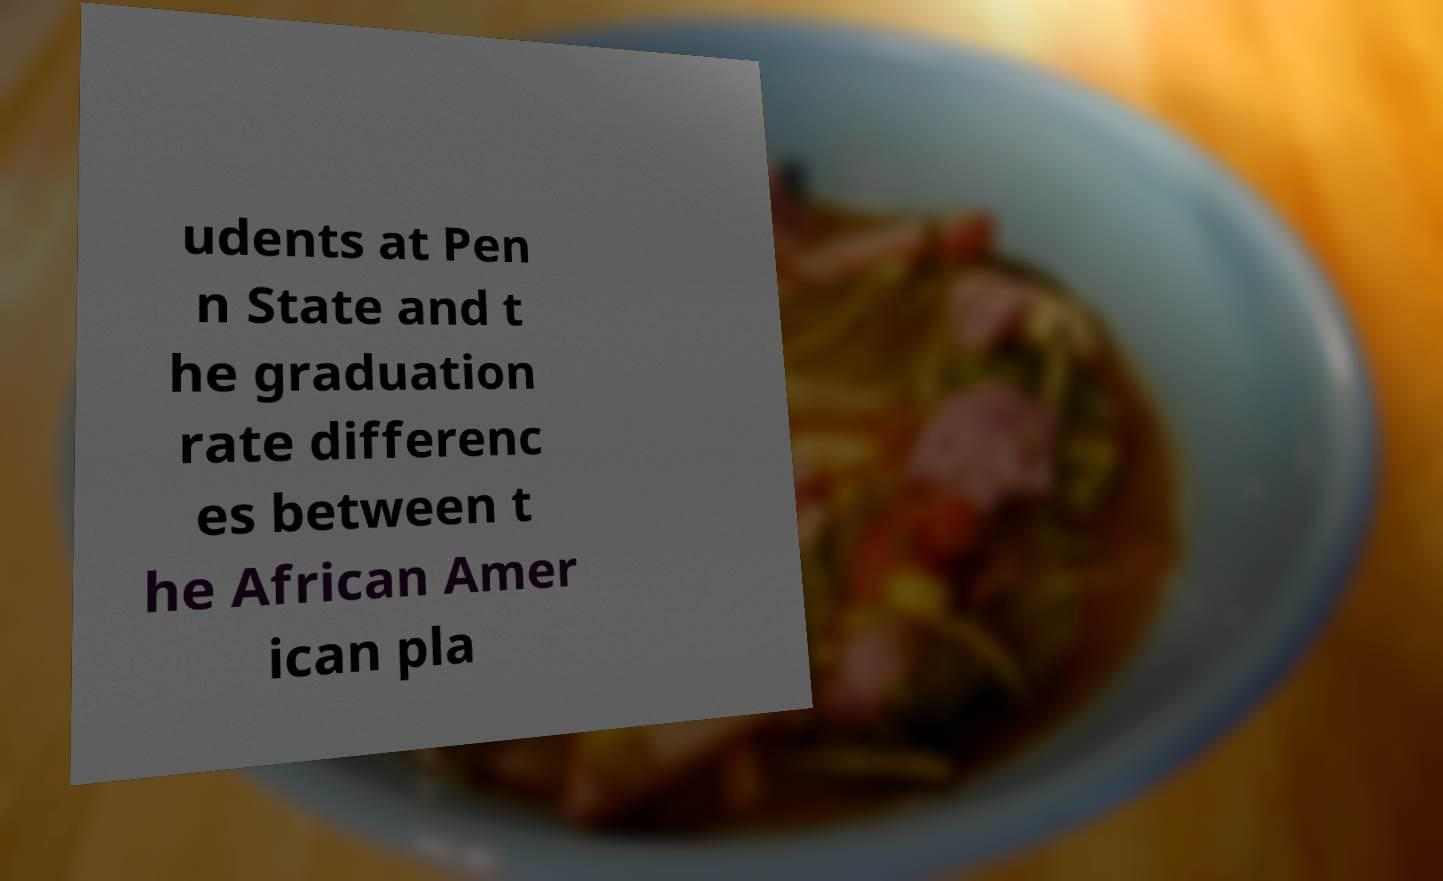Can you read and provide the text displayed in the image?This photo seems to have some interesting text. Can you extract and type it out for me? udents at Pen n State and t he graduation rate differenc es between t he African Amer ican pla 